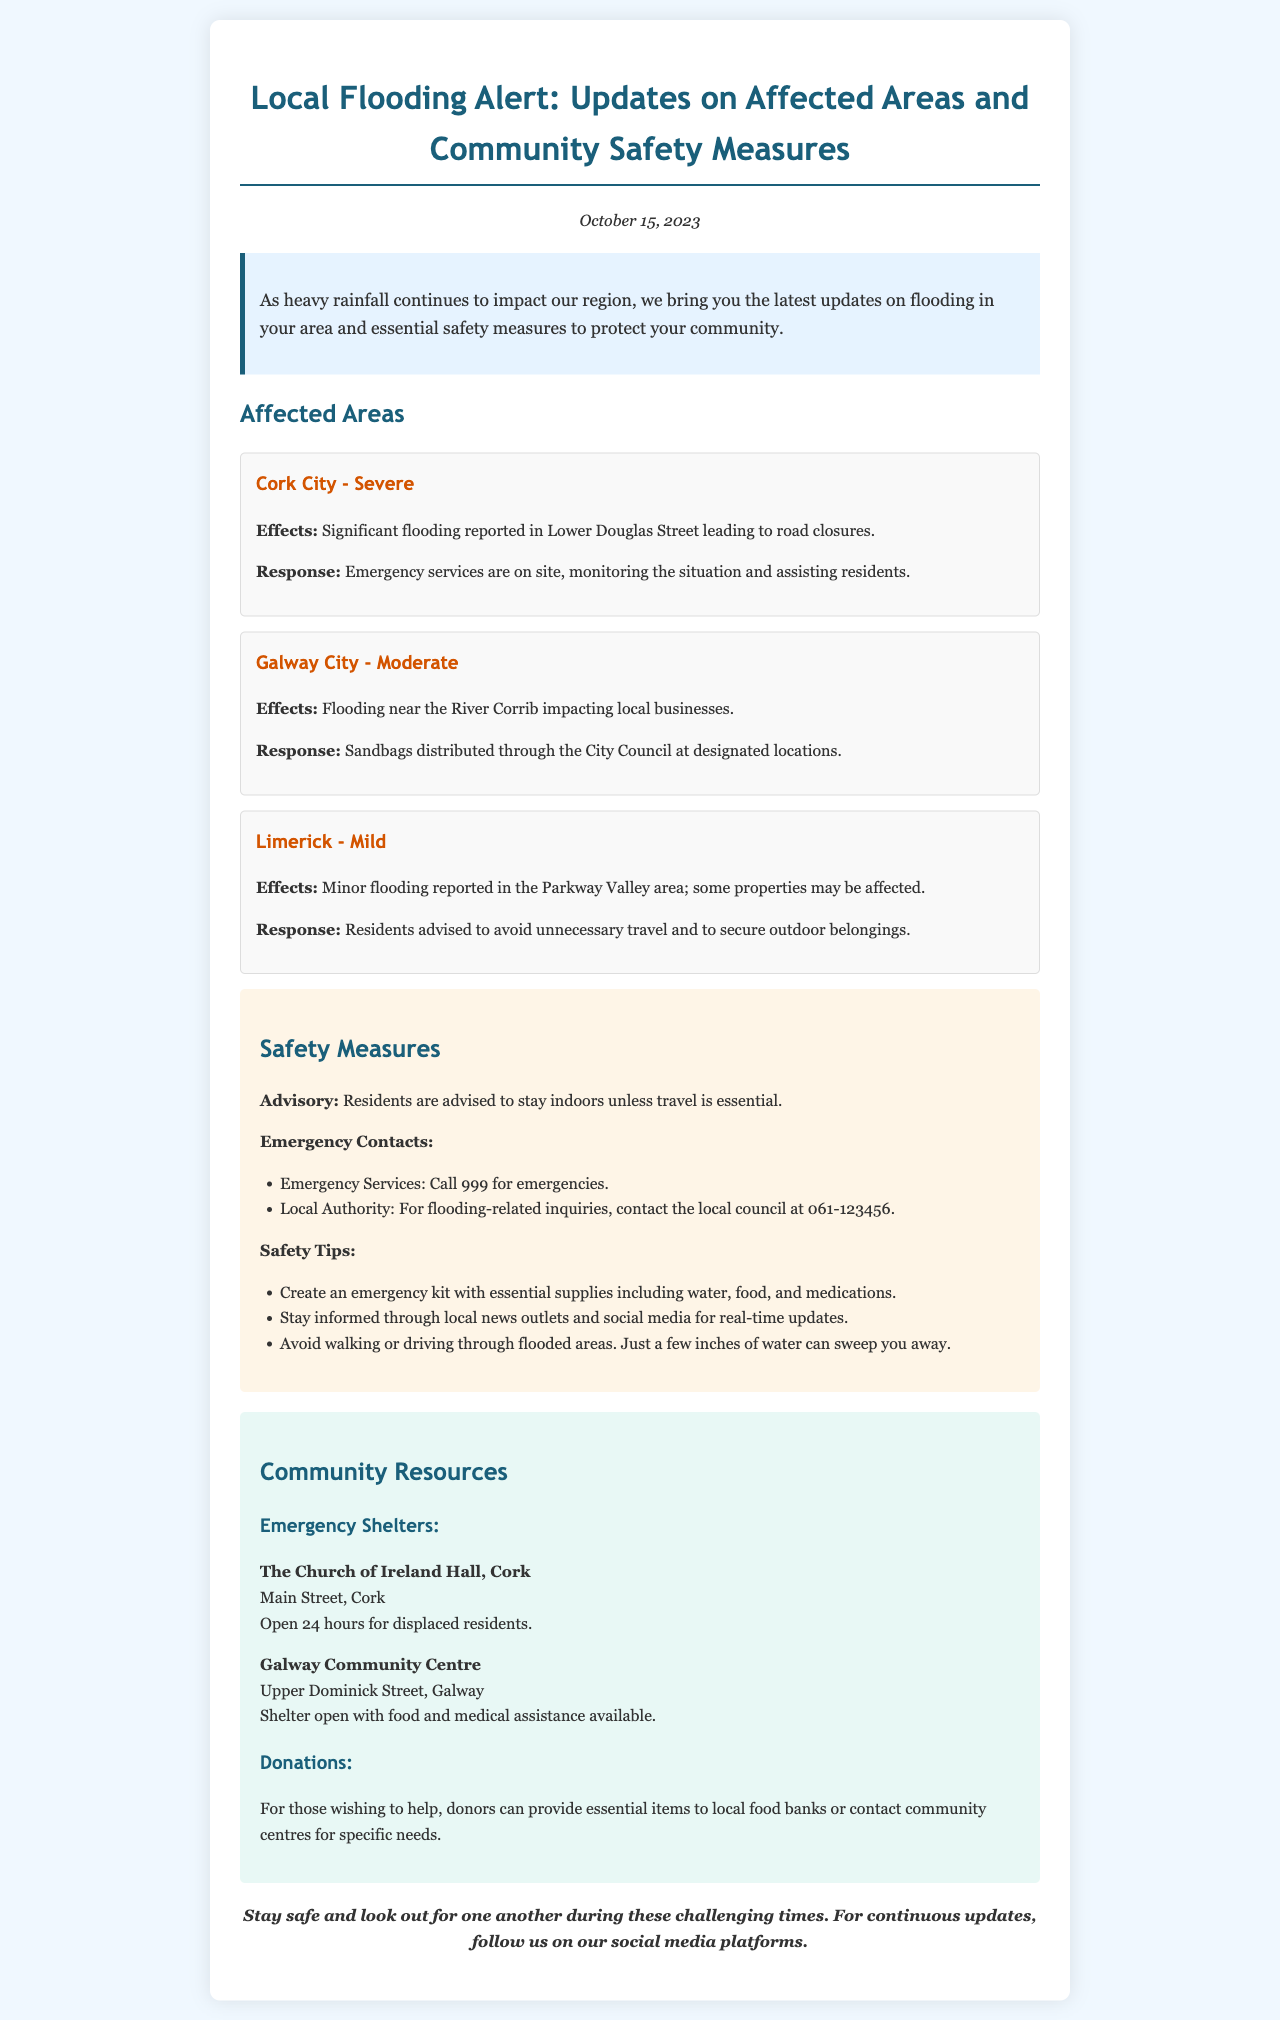What is the date of the newsletter? The date of the newsletter is mentioned prominently at the top, indicating when the information was published.
Answer: October 15, 2023 Which area is facing severe flooding? The document lists affected areas along with their severity, specifically mentioning the one with severe flooding.
Answer: Cork City What are the emergency contact numbers provided? The document specifies emergency contact numbers for various situations, highlighting the necessary information for residents.
Answer: 999, 061-123456 What safety tip advises against travel? The document outlines various safety tips, particularly stressing the importance of staying safe when it comes to flooded areas.
Answer: Avoid walking or driving through flooded areas Where is the emergency shelter in Cork located? The document details community resources, including specific locations for emergency shelters available to residents.
Answer: The Church of Ireland Hall, Cork How many areas reported flooding in total? The document lists specific regions affected by flooding, allowing for a tally of the locations mentioned.
Answer: Three What is one of the resources available for donations? The document outlines ways the community can help, including donations, specifying a type of resource mentioned.
Answer: Local food banks What is the advisory for residents during flooding? The newsletter provides crucial advisory information that affects community behavior during the flooding events.
Answer: Stay indoors unless travel is essential 